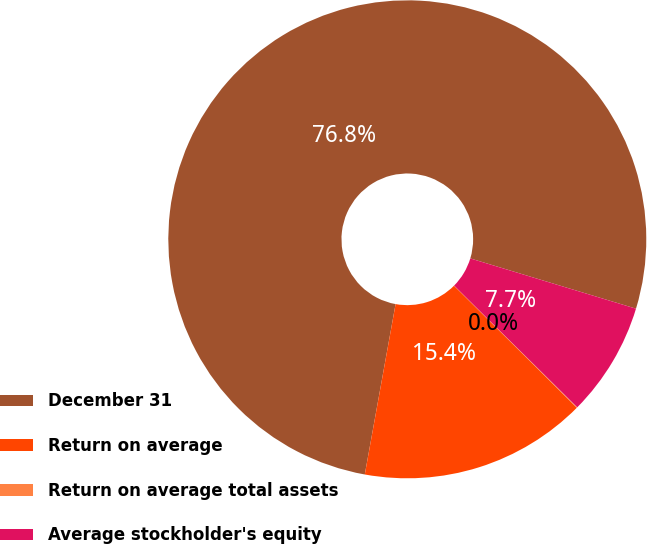Convert chart. <chart><loc_0><loc_0><loc_500><loc_500><pie_chart><fcel>December 31<fcel>Return on average<fcel>Return on average total assets<fcel>Average stockholder's equity<nl><fcel>76.84%<fcel>15.4%<fcel>0.04%<fcel>7.72%<nl></chart> 